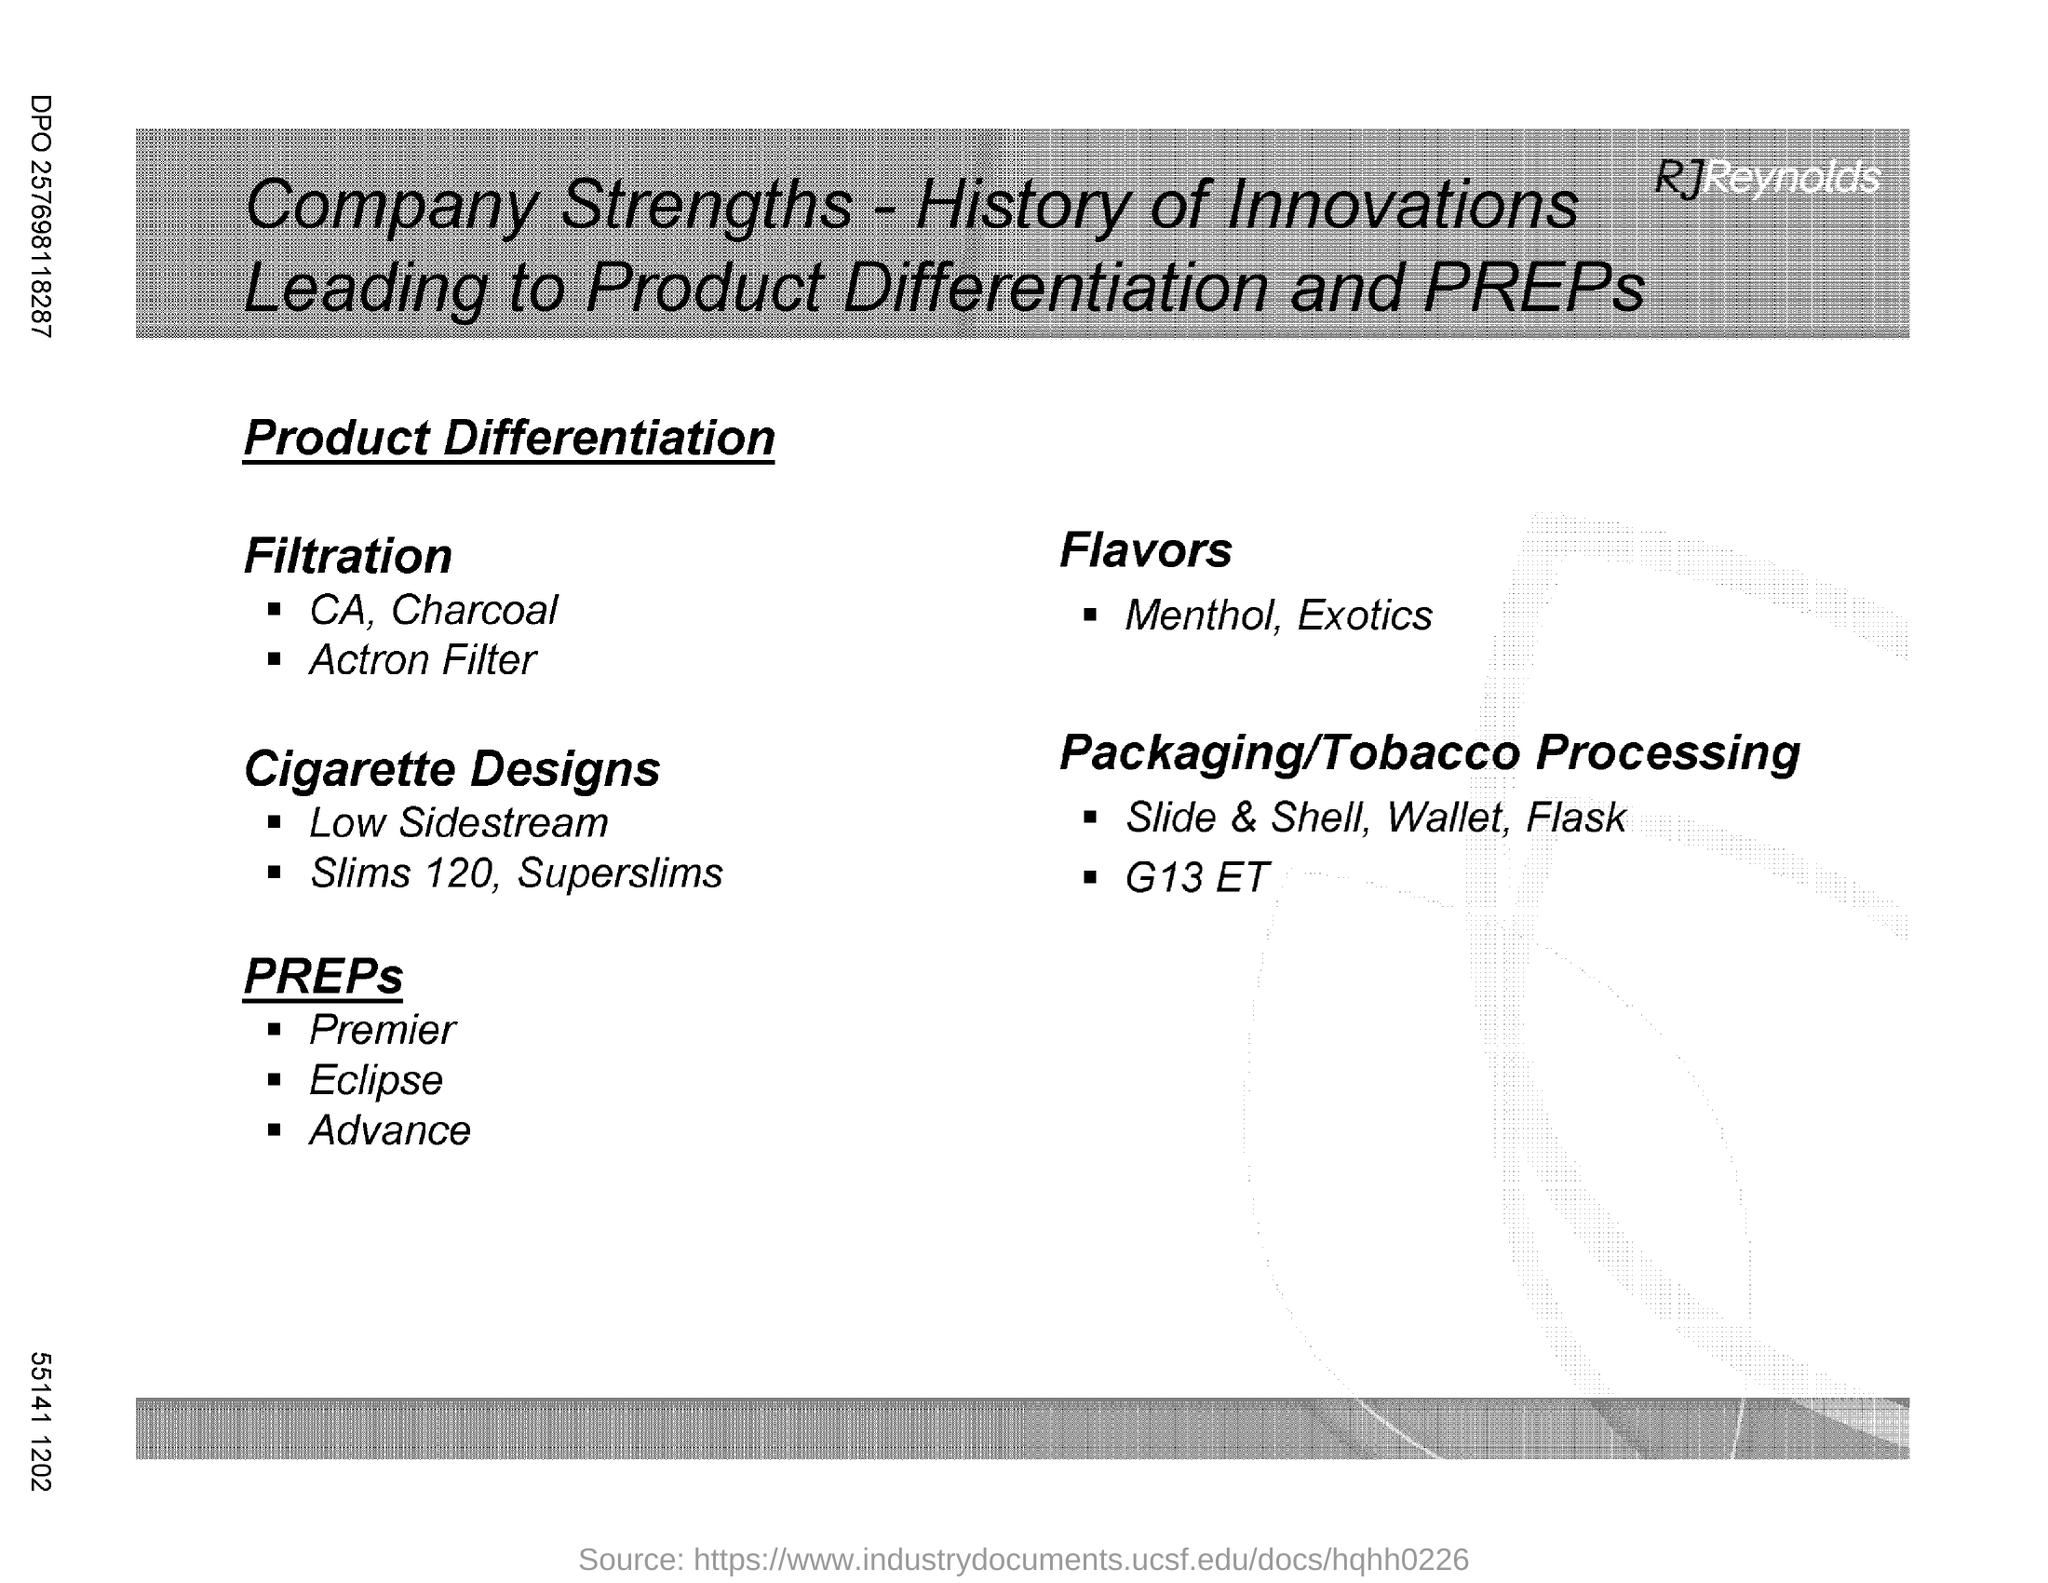Outline some significant characteristics in this image. The flavors mentioned are menthol and exotic flavors. 